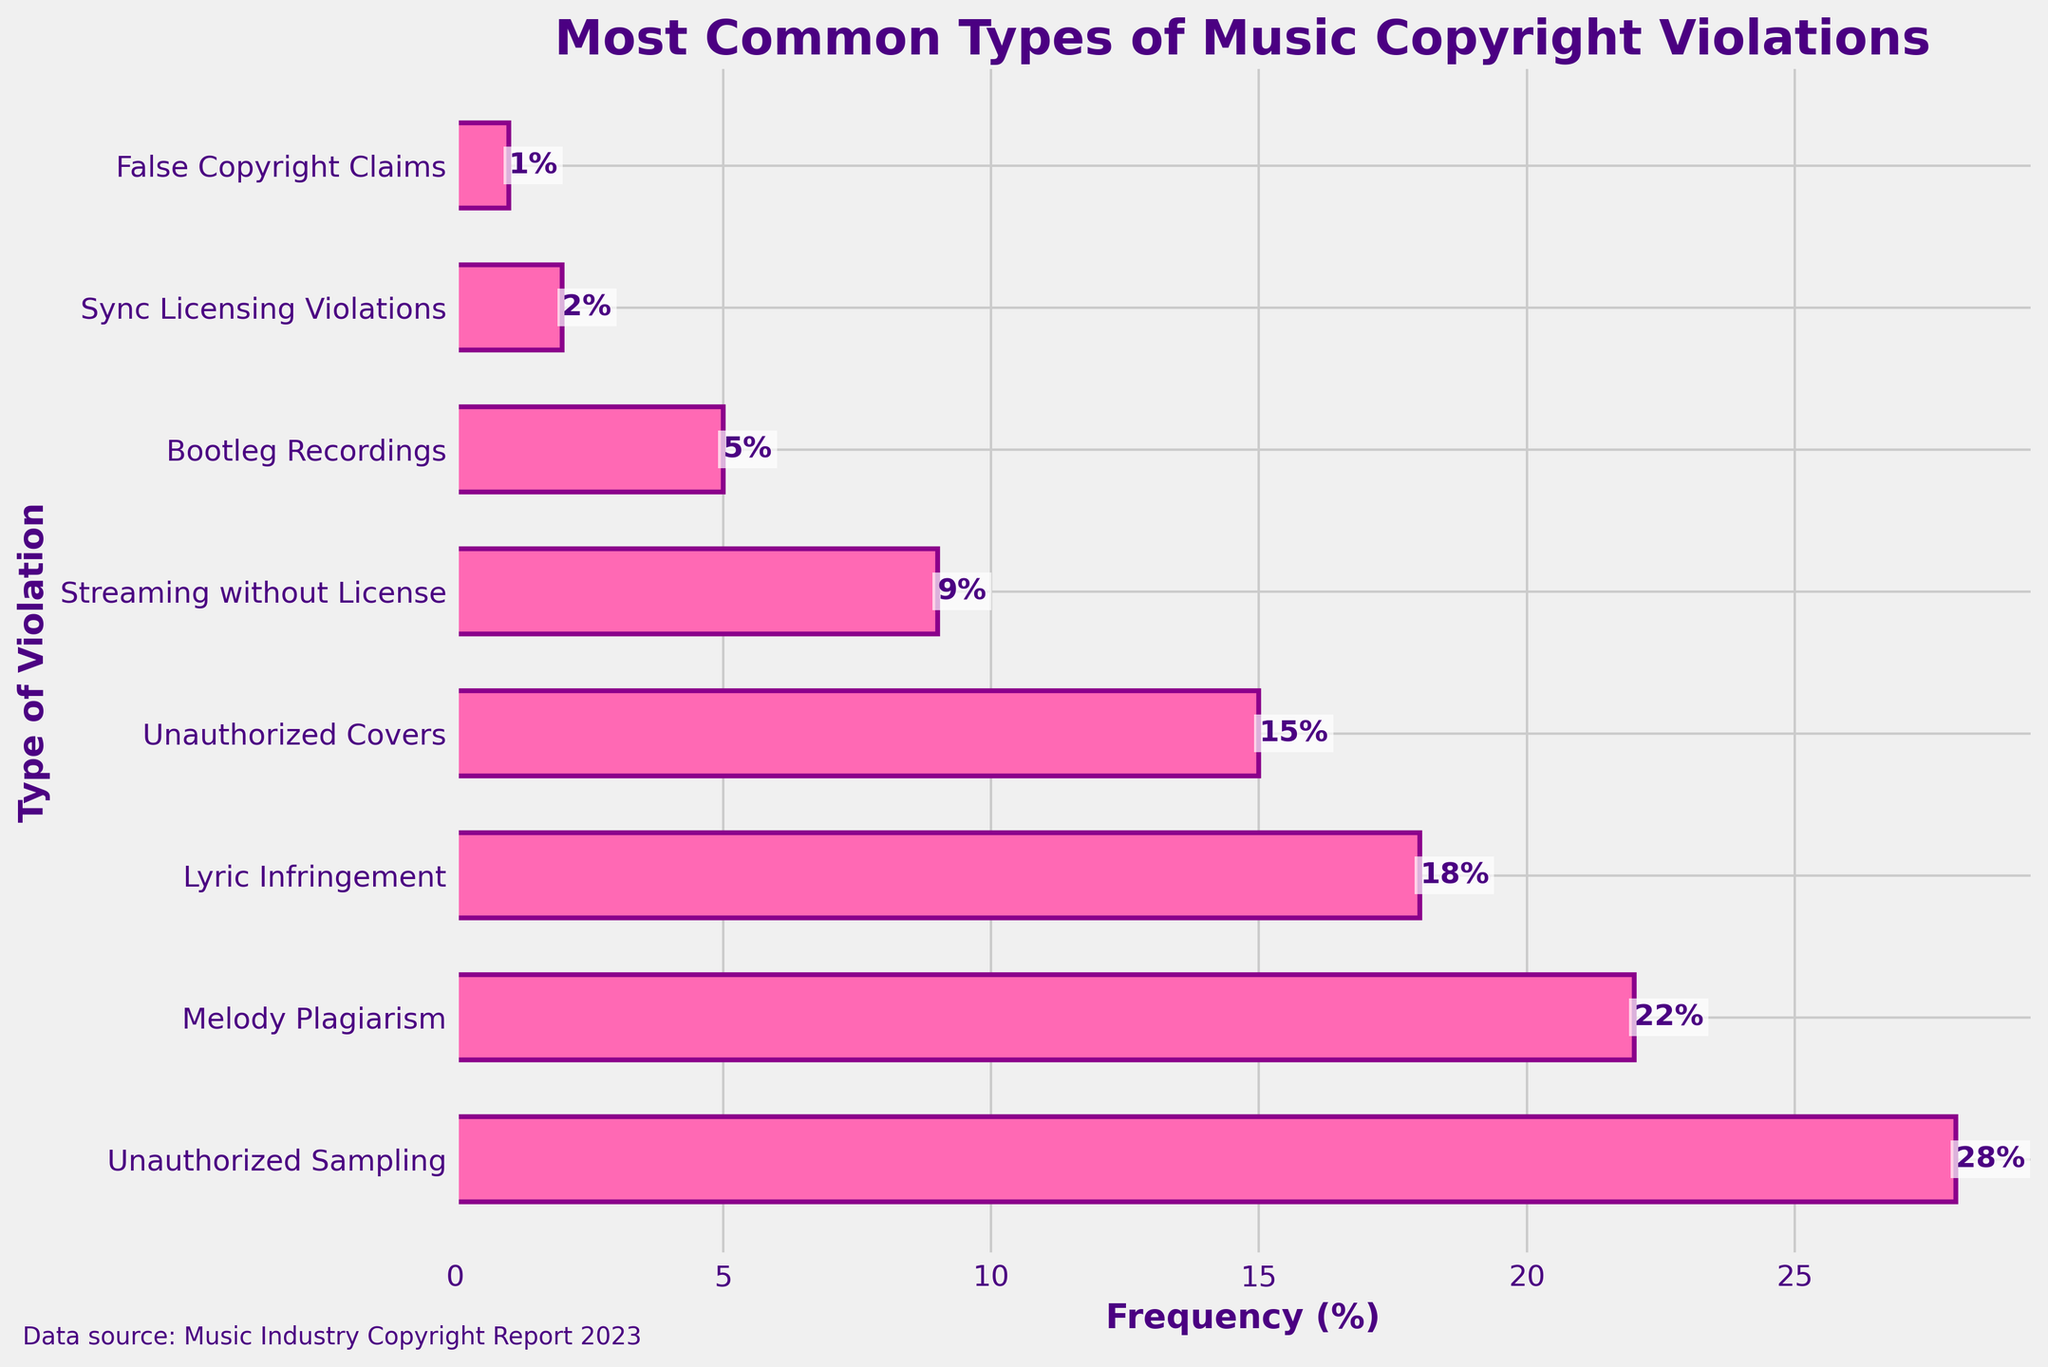What is the most common type of music copyright violation? By looking at the chart, the type of violation with the highest frequency percentage is the most common. "Unauthorized Sampling" has the highest frequency at 28%.
Answer: Unauthorized Sampling What is the least common type of music copyright violation? By observing the bars, the type of violation with the smallest bar (lowest percentage) is the least common. "False Copyright Claims" has the lowest frequency at 1%.
Answer: False Copyright Claims What is the total frequency percentage of Melody Plagiarism and Lyric Infringement combined? The chart shows the frequencies indicating Melody Plagiarism at 22% and Lyric Infringement at 18%. Adding these gives 22% + 18% = 40%.
Answer: 40% How much more common is Unauthorized Sampling compared to Streaming without License? The frequency of Unauthorized Sampling is 28%, and Streaming without License is 9%. The difference is 28% - 9% = 19%.
Answer: 19% Which type of violation is more frequent: Unauthorized Covers or Bootleg Recordings? Comparing the bar lengths, Unauthorized Covers has a frequency of 15%, while Bootleg Recordings has 5%. Unauthorized Covers is more frequent.
Answer: Unauthorized Covers What is the average frequency of Sync Licensing Violations, Bootleg Recordings, and False Copyright Claims? Adding the frequencies (2% + 5% + 1%) gives 8%. Dividing by the number of types (3) gives 8% / 3 ≈ 2.67%.
Answer: 2.67% Which three types of violations have frequencies higher than 15%? By scanning the chart, the types with frequencies above 15% are Unauthorized Sampling (28%), Melody Plagiarism (22%), and Lyric Infringement (18%).
Answer: Unauthorized Sampling, Melody Plagiarism, Lyric Infringement What is the combined frequency of Unauthorized Covers and Sync Licensing Violations? Unauthorized Covers have a frequency of 15%, and Sync Licensing Violations have 2%. Adding these gives 15% + 2% = 17%.
Answer: 17% Which type of infringement is exactly half as common as Unauthorized Sampling? Unauthorized Sampling has 28%. Half of this is 28% / 2 = 14%, but none match exactly. The closest is Unauthorized Covers at 15%.
Answer: None exactly, closest is Unauthorized Covers What is the median frequency of all the types of violations? Listing the percentages in order: 1%, 2%, 5%, 9%, 15%, 18%, 22%, 28%. The middle values are 15% and 18%. The median is (15% + 18%) / 2 = 16.5%.
Answer: 16.5% 